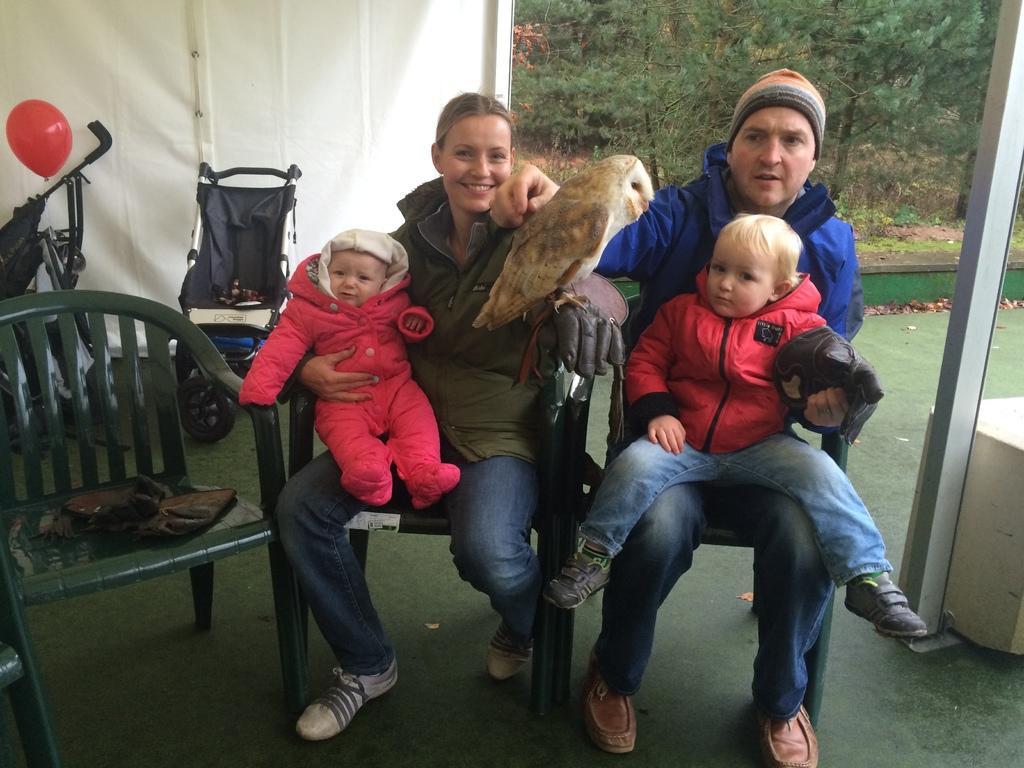Please provide a concise description of this image. In this picture there are two people sitting and holding the kids and there is a board on the woman hand and there are chairs and there is an object and there is a balloon. At the back there might be wall and there are trees. At the bottom there is water and there is ground. 